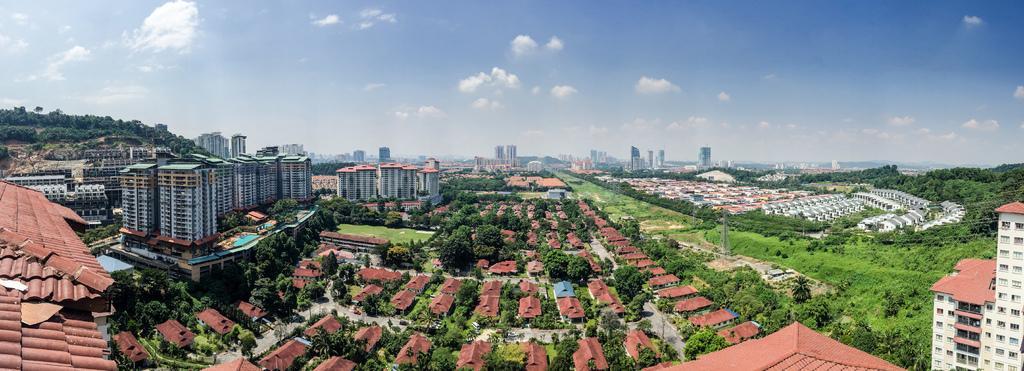How would you summarize this image in a sentence or two? In this image we can see there are buildings, trees, grass and houses. At the top we can see the sky. 